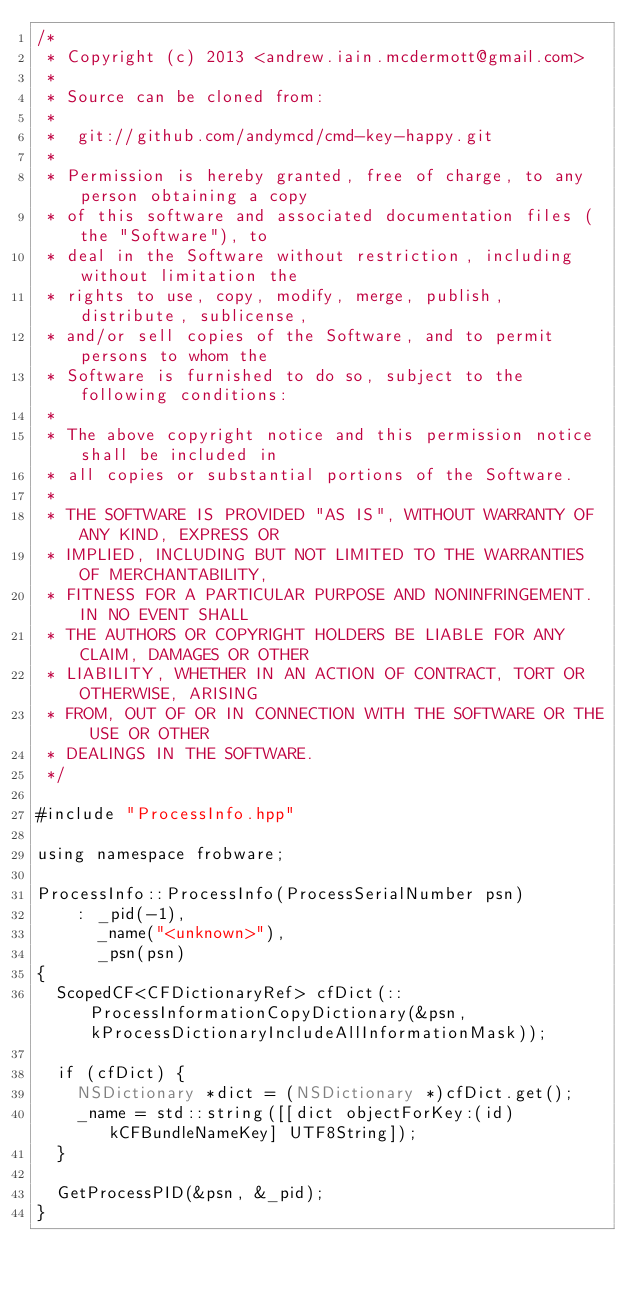<code> <loc_0><loc_0><loc_500><loc_500><_ObjectiveC_>/*
 * Copyright (c) 2013 <andrew.iain.mcdermott@gmail.com>
 *
 * Source can be cloned from:
 *
 * 	git://github.com/andymcd/cmd-key-happy.git
 *
 * Permission is hereby granted, free of charge, to any person obtaining a copy
 * of this software and associated documentation files (the "Software"), to
 * deal in the Software without restriction, including without limitation the
 * rights to use, copy, modify, merge, publish, distribute, sublicense,
 * and/or sell copies of the Software, and to permit persons to whom the
 * Software is furnished to do so, subject to the following conditions:
 *
 * The above copyright notice and this permission notice shall be included in
 * all copies or substantial portions of the Software.
 *
 * THE SOFTWARE IS PROVIDED "AS IS", WITHOUT WARRANTY OF ANY KIND, EXPRESS OR
 * IMPLIED, INCLUDING BUT NOT LIMITED TO THE WARRANTIES OF MERCHANTABILITY,
 * FITNESS FOR A PARTICULAR PURPOSE AND NONINFRINGEMENT. IN NO EVENT SHALL
 * THE AUTHORS OR COPYRIGHT HOLDERS BE LIABLE FOR ANY CLAIM, DAMAGES OR OTHER
 * LIABILITY, WHETHER IN AN ACTION OF CONTRACT, TORT OR OTHERWISE, ARISING
 * FROM, OUT OF OR IN CONNECTION WITH THE SOFTWARE OR THE USE OR OTHER
 * DEALINGS IN THE SOFTWARE.
 */

#include "ProcessInfo.hpp"

using namespace frobware;

ProcessInfo::ProcessInfo(ProcessSerialNumber psn)
    : _pid(-1),
      _name("<unknown>"),
      _psn(psn)
{
  ScopedCF<CFDictionaryRef> cfDict(::ProcessInformationCopyDictionary(&psn, kProcessDictionaryIncludeAllInformationMask));

  if (cfDict) {
    NSDictionary *dict = (NSDictionary *)cfDict.get();
    _name = std::string([[dict objectForKey:(id)kCFBundleNameKey] UTF8String]);
  }

  GetProcessPID(&psn, &_pid);
}
</code> 